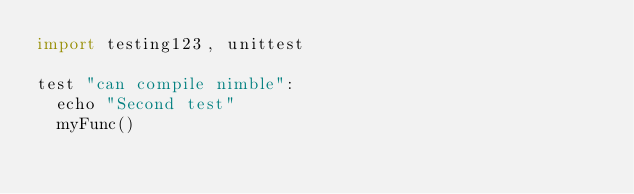<code> <loc_0><loc_0><loc_500><loc_500><_Nim_>import testing123, unittest

test "can compile nimble":
  echo "Second test"
  myFunc()


</code> 